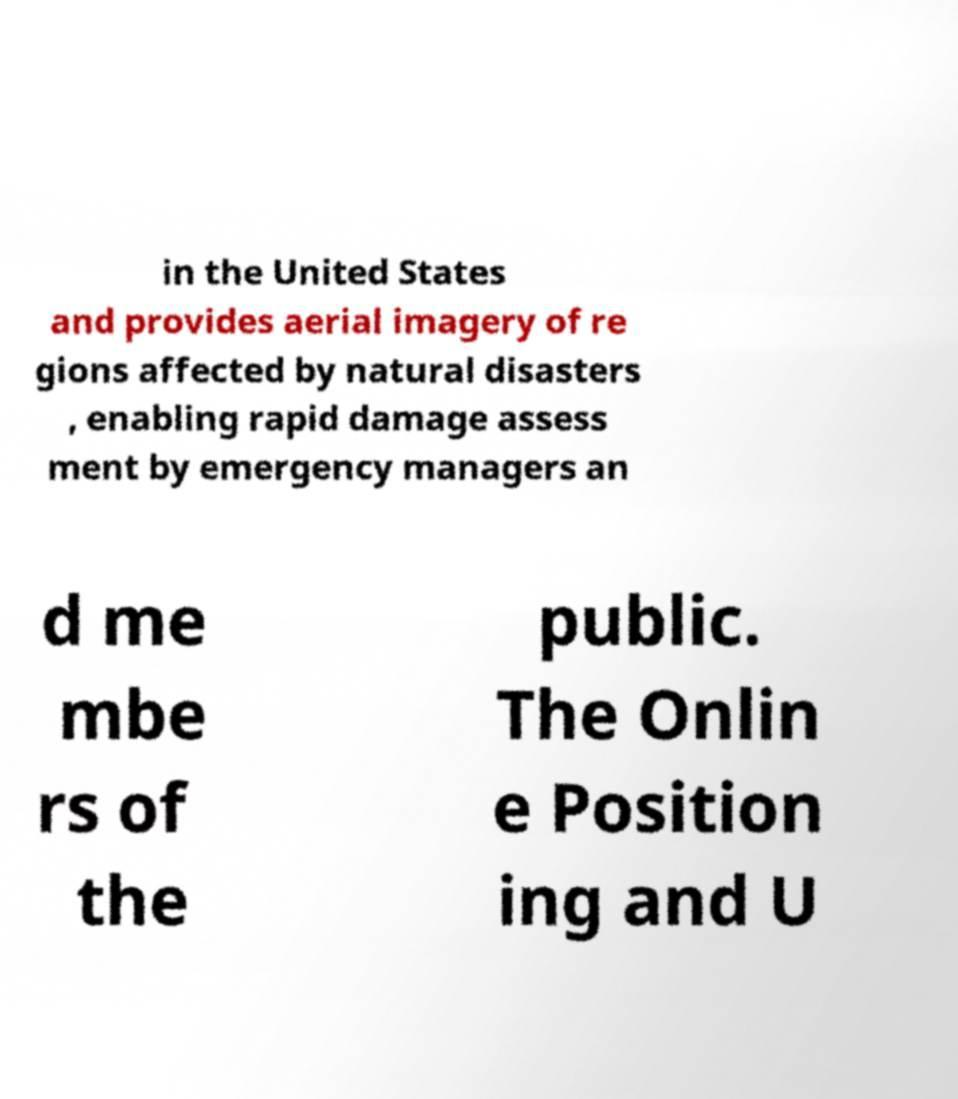Please identify and transcribe the text found in this image. in the United States and provides aerial imagery of re gions affected by natural disasters , enabling rapid damage assess ment by emergency managers an d me mbe rs of the public. The Onlin e Position ing and U 